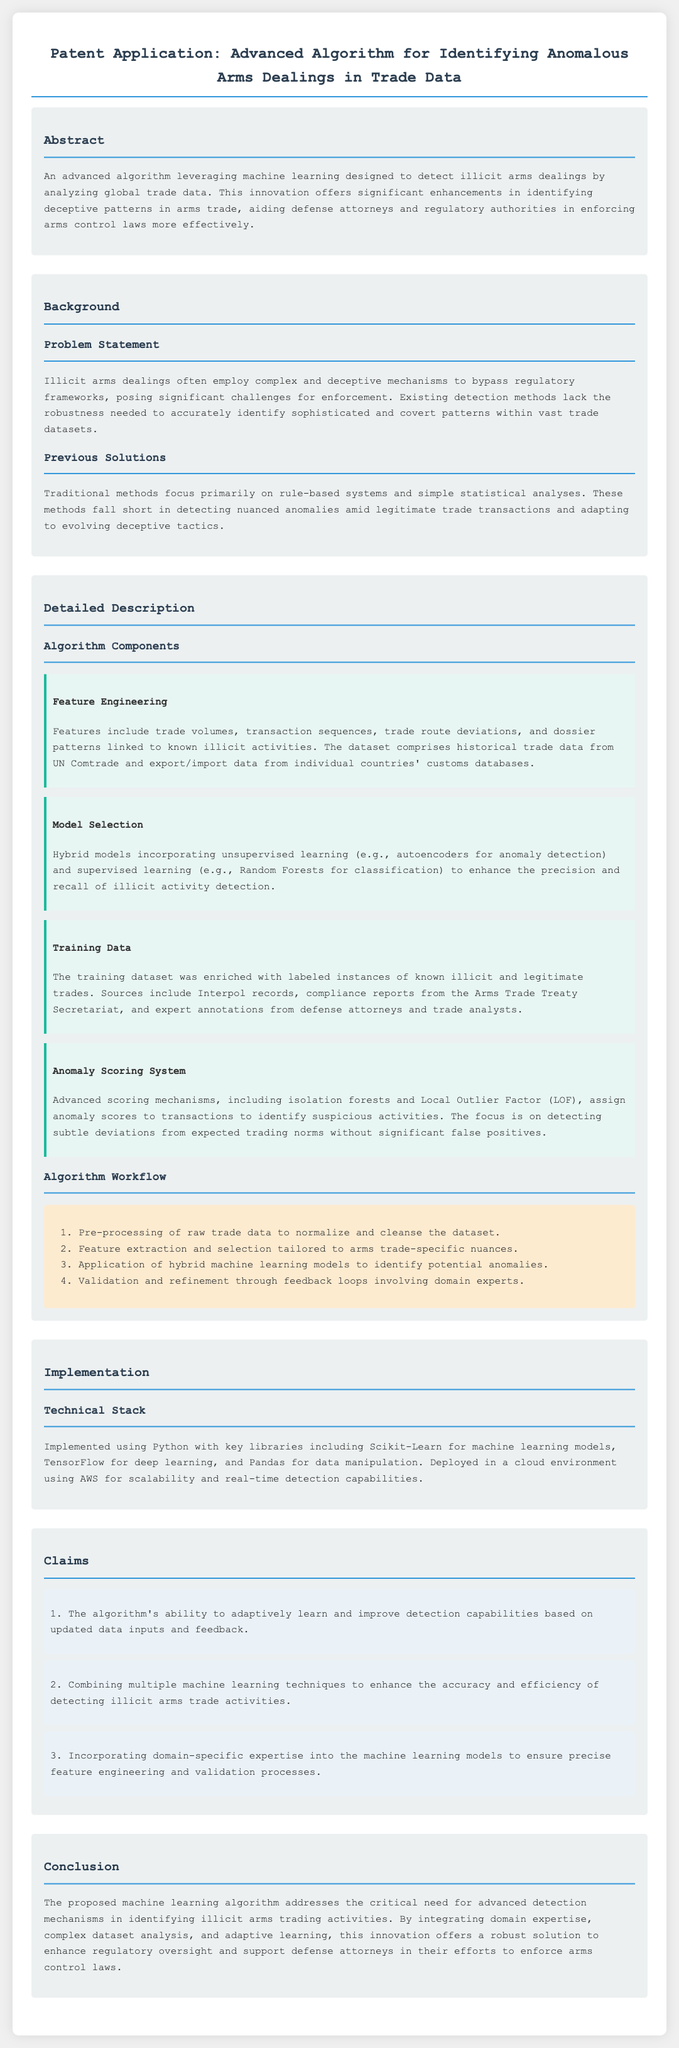What is the main purpose of the algorithm? The main purpose is to detect illicit arms dealings by analyzing global trade data.
Answer: Detect illicit arms dealings What machine learning techniques are combined in the algorithm? The algorithm combines unsupervised learning and supervised learning techniques.
Answer: Unsupervised and supervised learning What sources are used to enrich the training data? The training dataset sources include Interpol records and compliance reports from the Arms Trade Treaty Secretariat.
Answer: Interpol records, compliance reports What is the focus of the anomaly scoring system? The focus is on detecting subtle deviations from expected trading norms.
Answer: Detecting subtle deviations How many claims are presented in the patent application? There are three claims outlined in the document.
Answer: Three claims What is the implementation language of the algorithm? The algorithm is implemented using Python.
Answer: Python What type of models is used for anomaly detection? The models used for anomaly detection include autoencoders.
Answer: Autoencoders What is the main audience for this patent application? The main audience includes defense attorneys and regulatory authorities.
Answer: Defense attorneys and regulatory authorities What is the problem posed by illicit arms dealings? Illicit arms dealings pose significant challenges for enforcement.
Answer: Significant challenges for enforcement 